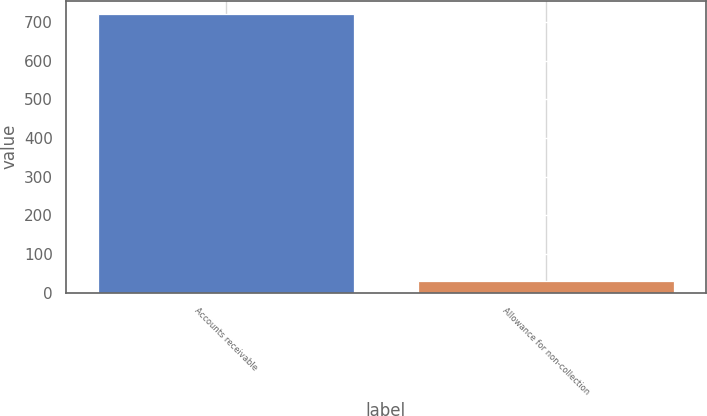Convert chart to OTSL. <chart><loc_0><loc_0><loc_500><loc_500><bar_chart><fcel>Accounts receivable<fcel>Allowance for non-collection<nl><fcel>720<fcel>30<nl></chart> 